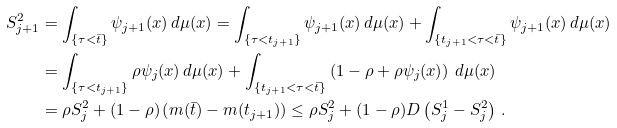<formula> <loc_0><loc_0><loc_500><loc_500>S ^ { 2 } _ { j + 1 } & = \int _ { \{ \tau < \bar { t } \} } \psi _ { j + 1 } ( x ) \, d \mu ( x ) = \int _ { \{ \tau < t _ { j + 1 } \} } \psi _ { j + 1 } ( x ) \, d \mu ( x ) + \int _ { \{ t _ { j + 1 } < \tau < \bar { t } \} } \psi _ { j + 1 } ( x ) \, d \mu ( x ) \\ & = \int _ { \{ \tau < t _ { j + 1 } \} } \rho \psi _ { j } ( x ) \, d \mu ( x ) + \int _ { \{ t _ { j + 1 } < \tau < \bar { t } \} } \left ( 1 - \rho + \rho \psi _ { j } ( x ) \right ) \, d \mu ( x ) \\ & = \rho S ^ { 2 } _ { j } + \left ( 1 - \rho \right ) \left ( m ( \bar { t } ) - m ( t _ { j + 1 } ) \right ) \leq \rho S ^ { 2 } _ { j } + ( 1 - \rho ) D \left ( S ^ { 1 } _ { j } - S ^ { 2 } _ { j } \right ) \, .</formula> 